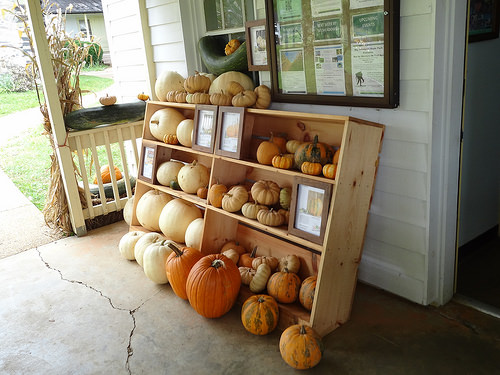<image>
Is there a pumpkin on the shelf? No. The pumpkin is not positioned on the shelf. They may be near each other, but the pumpkin is not supported by or resting on top of the shelf. 